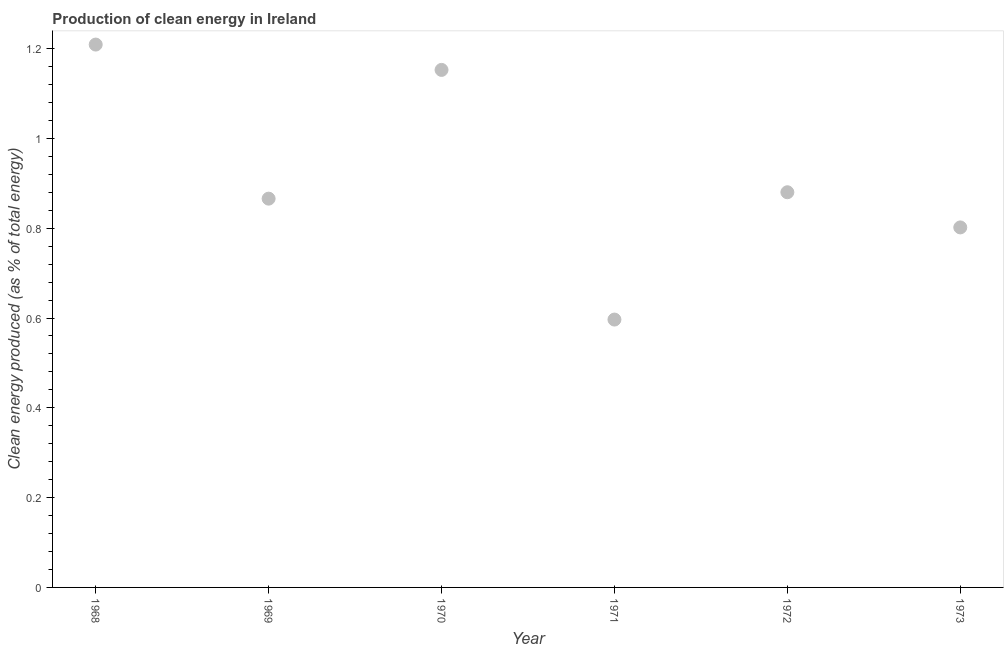What is the production of clean energy in 1969?
Your answer should be compact. 0.87. Across all years, what is the maximum production of clean energy?
Make the answer very short. 1.21. Across all years, what is the minimum production of clean energy?
Your response must be concise. 0.6. In which year was the production of clean energy maximum?
Keep it short and to the point. 1968. What is the sum of the production of clean energy?
Your answer should be compact. 5.51. What is the difference between the production of clean energy in 1968 and 1969?
Provide a succinct answer. 0.34. What is the average production of clean energy per year?
Make the answer very short. 0.92. What is the median production of clean energy?
Your response must be concise. 0.87. In how many years, is the production of clean energy greater than 0.8 %?
Offer a very short reply. 5. Do a majority of the years between 1968 and 1971 (inclusive) have production of clean energy greater than 0.08 %?
Offer a very short reply. Yes. What is the ratio of the production of clean energy in 1970 to that in 1973?
Make the answer very short. 1.44. What is the difference between the highest and the second highest production of clean energy?
Ensure brevity in your answer.  0.06. Is the sum of the production of clean energy in 1970 and 1972 greater than the maximum production of clean energy across all years?
Provide a short and direct response. Yes. What is the difference between the highest and the lowest production of clean energy?
Keep it short and to the point. 0.61. In how many years, is the production of clean energy greater than the average production of clean energy taken over all years?
Your answer should be very brief. 2. Does the production of clean energy monotonically increase over the years?
Offer a terse response. No. Are the values on the major ticks of Y-axis written in scientific E-notation?
Provide a succinct answer. No. Does the graph contain grids?
Provide a succinct answer. No. What is the title of the graph?
Keep it short and to the point. Production of clean energy in Ireland. What is the label or title of the Y-axis?
Your response must be concise. Clean energy produced (as % of total energy). What is the Clean energy produced (as % of total energy) in 1968?
Your answer should be very brief. 1.21. What is the Clean energy produced (as % of total energy) in 1969?
Provide a short and direct response. 0.87. What is the Clean energy produced (as % of total energy) in 1970?
Offer a terse response. 1.15. What is the Clean energy produced (as % of total energy) in 1971?
Ensure brevity in your answer.  0.6. What is the Clean energy produced (as % of total energy) in 1972?
Keep it short and to the point. 0.88. What is the Clean energy produced (as % of total energy) in 1973?
Make the answer very short. 0.8. What is the difference between the Clean energy produced (as % of total energy) in 1968 and 1969?
Offer a terse response. 0.34. What is the difference between the Clean energy produced (as % of total energy) in 1968 and 1970?
Your answer should be compact. 0.06. What is the difference between the Clean energy produced (as % of total energy) in 1968 and 1971?
Your response must be concise. 0.61. What is the difference between the Clean energy produced (as % of total energy) in 1968 and 1972?
Make the answer very short. 0.33. What is the difference between the Clean energy produced (as % of total energy) in 1968 and 1973?
Keep it short and to the point. 0.41. What is the difference between the Clean energy produced (as % of total energy) in 1969 and 1970?
Your response must be concise. -0.29. What is the difference between the Clean energy produced (as % of total energy) in 1969 and 1971?
Provide a succinct answer. 0.27. What is the difference between the Clean energy produced (as % of total energy) in 1969 and 1972?
Make the answer very short. -0.01. What is the difference between the Clean energy produced (as % of total energy) in 1969 and 1973?
Provide a short and direct response. 0.06. What is the difference between the Clean energy produced (as % of total energy) in 1970 and 1971?
Ensure brevity in your answer.  0.56. What is the difference between the Clean energy produced (as % of total energy) in 1970 and 1972?
Your answer should be very brief. 0.27. What is the difference between the Clean energy produced (as % of total energy) in 1970 and 1973?
Offer a terse response. 0.35. What is the difference between the Clean energy produced (as % of total energy) in 1971 and 1972?
Provide a short and direct response. -0.28. What is the difference between the Clean energy produced (as % of total energy) in 1971 and 1973?
Make the answer very short. -0.21. What is the difference between the Clean energy produced (as % of total energy) in 1972 and 1973?
Provide a short and direct response. 0.08. What is the ratio of the Clean energy produced (as % of total energy) in 1968 to that in 1969?
Provide a short and direct response. 1.4. What is the ratio of the Clean energy produced (as % of total energy) in 1968 to that in 1970?
Your response must be concise. 1.05. What is the ratio of the Clean energy produced (as % of total energy) in 1968 to that in 1971?
Your response must be concise. 2.03. What is the ratio of the Clean energy produced (as % of total energy) in 1968 to that in 1972?
Provide a short and direct response. 1.37. What is the ratio of the Clean energy produced (as % of total energy) in 1968 to that in 1973?
Give a very brief answer. 1.51. What is the ratio of the Clean energy produced (as % of total energy) in 1969 to that in 1970?
Offer a very short reply. 0.75. What is the ratio of the Clean energy produced (as % of total energy) in 1969 to that in 1971?
Ensure brevity in your answer.  1.45. What is the ratio of the Clean energy produced (as % of total energy) in 1969 to that in 1972?
Provide a short and direct response. 0.98. What is the ratio of the Clean energy produced (as % of total energy) in 1969 to that in 1973?
Your response must be concise. 1.08. What is the ratio of the Clean energy produced (as % of total energy) in 1970 to that in 1971?
Provide a short and direct response. 1.93. What is the ratio of the Clean energy produced (as % of total energy) in 1970 to that in 1972?
Your response must be concise. 1.31. What is the ratio of the Clean energy produced (as % of total energy) in 1970 to that in 1973?
Give a very brief answer. 1.44. What is the ratio of the Clean energy produced (as % of total energy) in 1971 to that in 1972?
Your answer should be very brief. 0.68. What is the ratio of the Clean energy produced (as % of total energy) in 1971 to that in 1973?
Provide a short and direct response. 0.74. What is the ratio of the Clean energy produced (as % of total energy) in 1972 to that in 1973?
Provide a short and direct response. 1.1. 